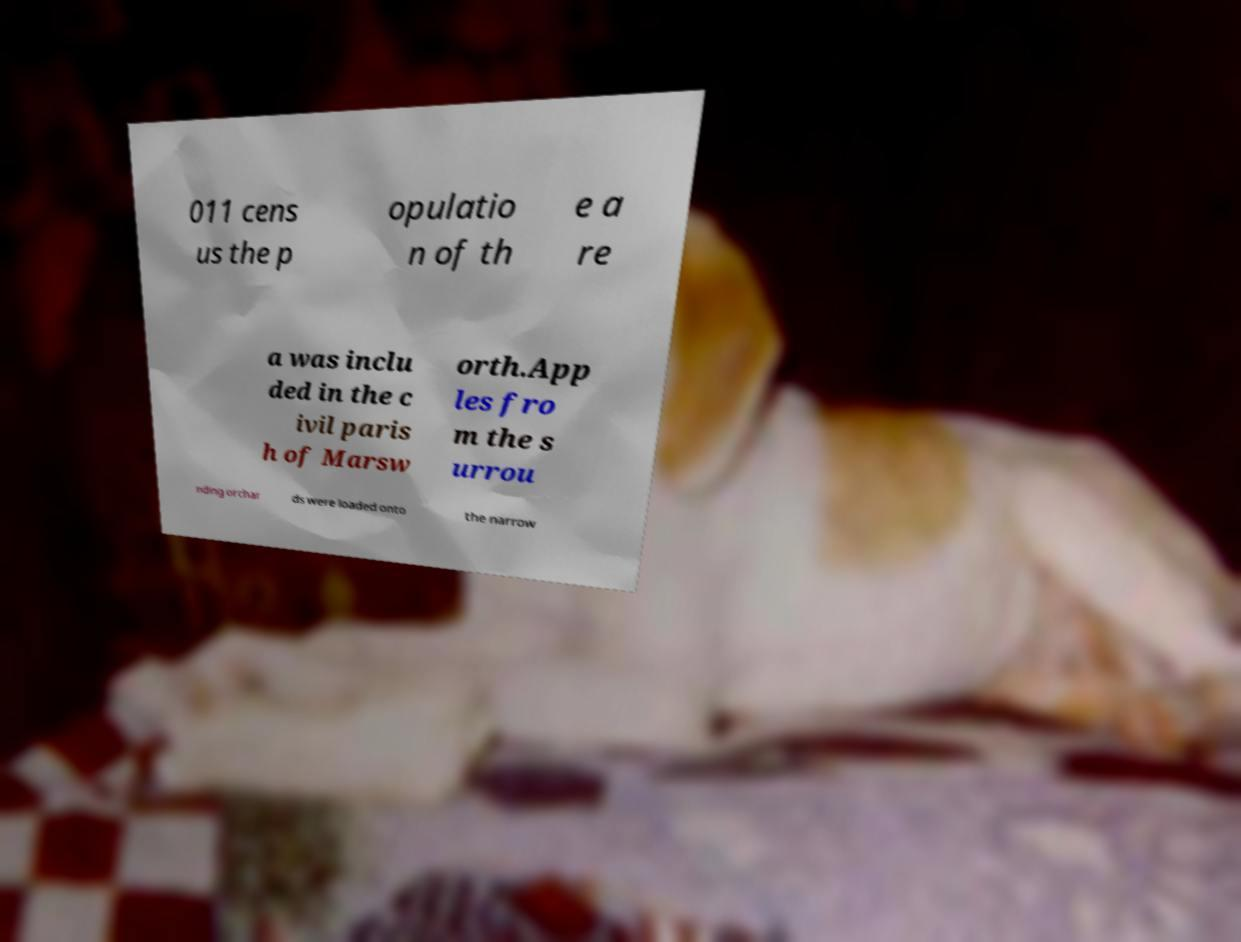For documentation purposes, I need the text within this image transcribed. Could you provide that? 011 cens us the p opulatio n of th e a re a was inclu ded in the c ivil paris h of Marsw orth.App les fro m the s urrou nding orchar ds were loaded onto the narrow 